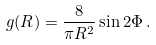Convert formula to latex. <formula><loc_0><loc_0><loc_500><loc_500>g ( { R } ) = \frac { 8 } { \pi R ^ { 2 } } \sin 2 \Phi \, .</formula> 